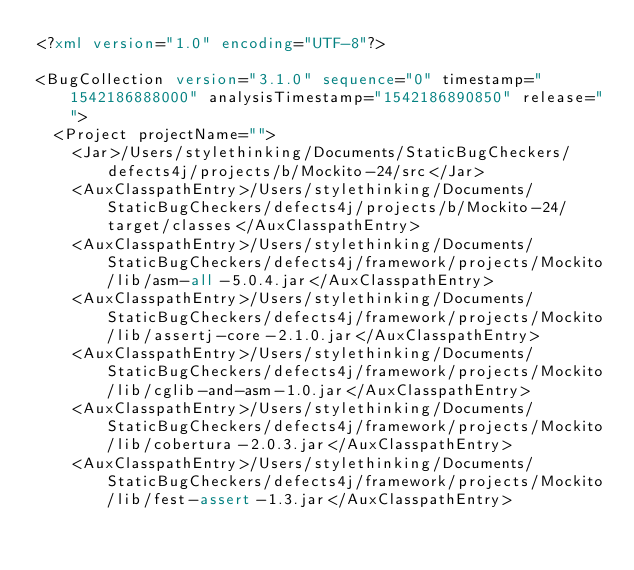<code> <loc_0><loc_0><loc_500><loc_500><_XML_><?xml version="1.0" encoding="UTF-8"?>

<BugCollection version="3.1.0" sequence="0" timestamp="1542186888000" analysisTimestamp="1542186890850" release="">
  <Project projectName="">
    <Jar>/Users/stylethinking/Documents/StaticBugCheckers/defects4j/projects/b/Mockito-24/src</Jar>
    <AuxClasspathEntry>/Users/stylethinking/Documents/StaticBugCheckers/defects4j/projects/b/Mockito-24/target/classes</AuxClasspathEntry>
    <AuxClasspathEntry>/Users/stylethinking/Documents/StaticBugCheckers/defects4j/framework/projects/Mockito/lib/asm-all-5.0.4.jar</AuxClasspathEntry>
    <AuxClasspathEntry>/Users/stylethinking/Documents/StaticBugCheckers/defects4j/framework/projects/Mockito/lib/assertj-core-2.1.0.jar</AuxClasspathEntry>
    <AuxClasspathEntry>/Users/stylethinking/Documents/StaticBugCheckers/defects4j/framework/projects/Mockito/lib/cglib-and-asm-1.0.jar</AuxClasspathEntry>
    <AuxClasspathEntry>/Users/stylethinking/Documents/StaticBugCheckers/defects4j/framework/projects/Mockito/lib/cobertura-2.0.3.jar</AuxClasspathEntry>
    <AuxClasspathEntry>/Users/stylethinking/Documents/StaticBugCheckers/defects4j/framework/projects/Mockito/lib/fest-assert-1.3.jar</AuxClasspathEntry></code> 